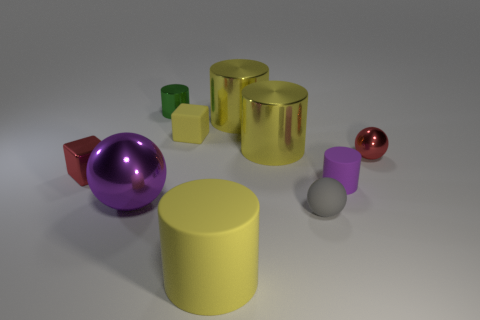How many yellow cylinders must be subtracted to get 1 yellow cylinders? 2 Subtract all green spheres. How many yellow cylinders are left? 3 Subtract all purple cylinders. How many cylinders are left? 4 Subtract 2 cylinders. How many cylinders are left? 3 Subtract all small green metallic cylinders. How many cylinders are left? 4 Subtract all brown cylinders. Subtract all blue cubes. How many cylinders are left? 5 Subtract all cubes. How many objects are left? 8 Add 2 big shiny things. How many big shiny things are left? 5 Add 3 yellow spheres. How many yellow spheres exist? 3 Subtract 0 gray cubes. How many objects are left? 10 